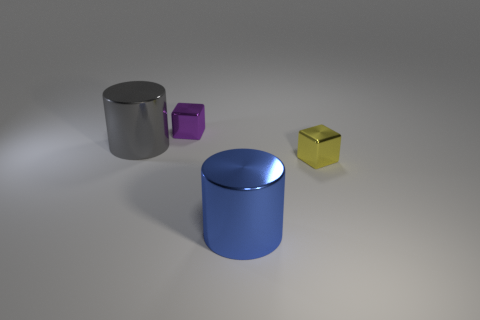What is the color of the small metal block that is to the left of the tiny yellow block in front of the big thing that is to the left of the small purple object?
Your response must be concise. Purple. Are there fewer purple blocks that are in front of the tiny yellow thing than small yellow metal cubes that are behind the big gray cylinder?
Offer a terse response. No. Is the shape of the large blue object the same as the yellow object?
Offer a very short reply. No. What number of blue objects are the same size as the purple thing?
Make the answer very short. 0. Are there fewer small blocks to the left of the purple block than big gray metallic cylinders?
Keep it short and to the point. Yes. There is a shiny cylinder that is on the right side of the gray metallic object to the left of the blue metallic cylinder; what is its size?
Provide a succinct answer. Large. What number of things are small purple metallic things or tiny metal objects?
Provide a short and direct response. 2. Are there fewer gray rubber things than gray metal things?
Ensure brevity in your answer.  Yes. How many objects are either large yellow matte cylinders or small objects that are left of the big blue shiny object?
Provide a short and direct response. 1. Are there any big blue things made of the same material as the large blue cylinder?
Your answer should be very brief. No. 